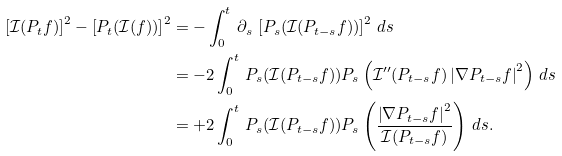Convert formula to latex. <formula><loc_0><loc_0><loc_500><loc_500>\left [ \mathcal { I } ( P _ { t } f ) \right ] ^ { 2 } - \left [ P _ { t } ( \mathcal { I } ( f ) ) \right ] ^ { 2 } & = - \int _ { 0 } ^ { t } \, \partial _ { s } \, \left [ P _ { s } ( \mathcal { I } ( P _ { t - s } f ) ) \right ] ^ { 2 } \, d s \\ & = - 2 \int _ { 0 } ^ { t } \, P _ { s } ( \mathcal { I } ( P _ { t - s } f ) ) P _ { s } \left ( \mathcal { I ^ { \prime \prime } } ( P _ { t - s } f ) \left | \nabla P _ { t - s } f \right | ^ { 2 } \right ) \, d s \\ & = + 2 \int _ { 0 } ^ { t } \, P _ { s } ( \mathcal { I } ( P _ { t - s } f ) ) P _ { s } \left ( \frac { \left | \nabla P _ { t - s } f \right | ^ { 2 } } { \mathcal { I } ( P _ { t - s } f ) } \right ) \, d s .</formula> 